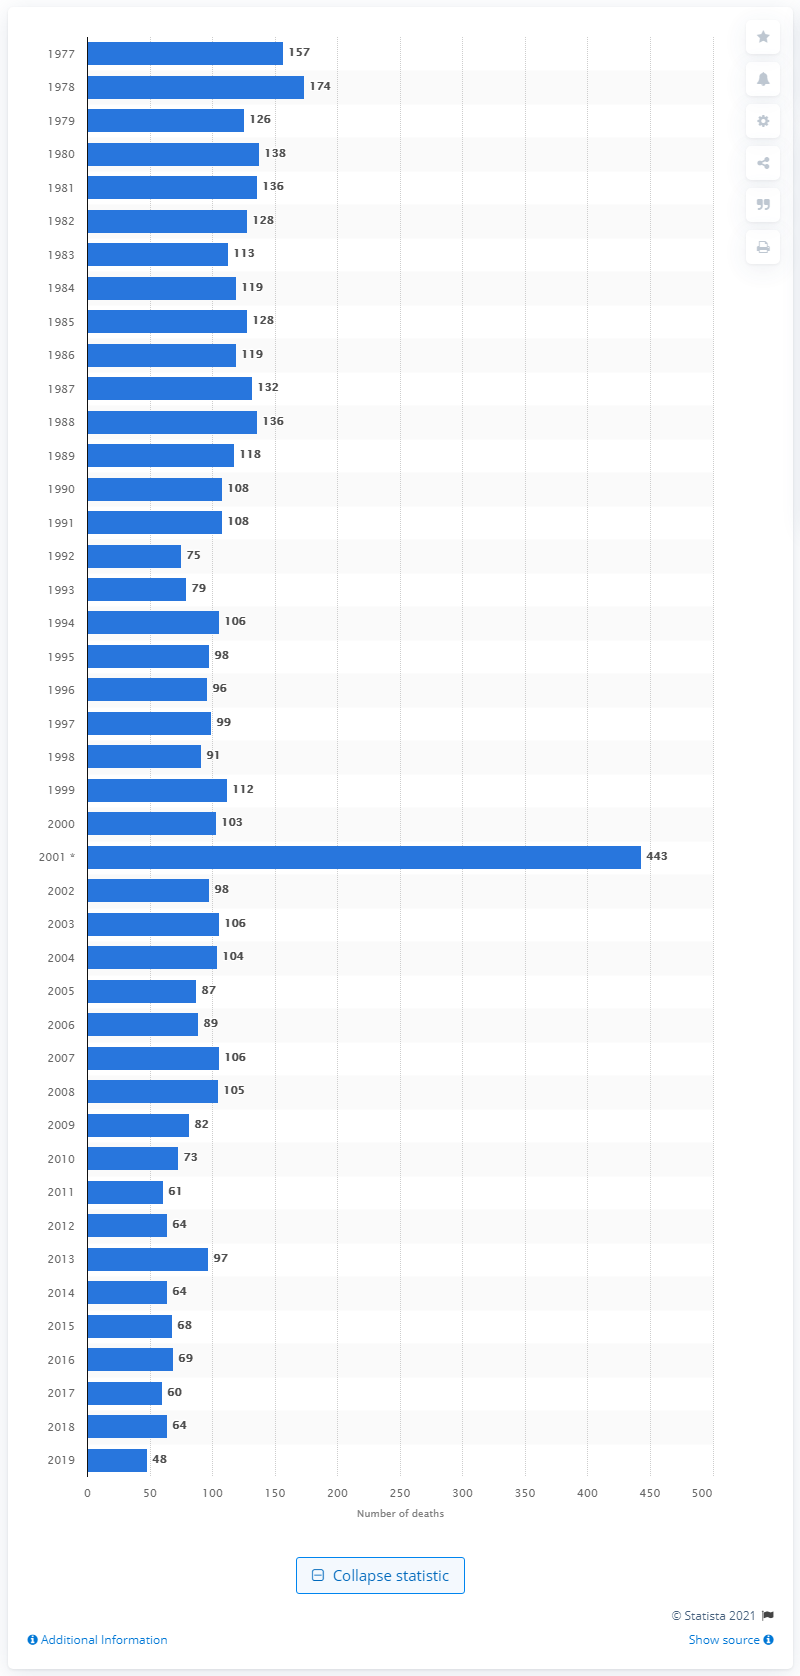Outline some significant characteristics in this image. In 2019, 48 firefighters lost their lives while on duty. Last year, 64 firefighters lost their lives in the line of duty. 